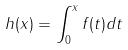Convert formula to latex. <formula><loc_0><loc_0><loc_500><loc_500>h ( x ) = \int _ { 0 } ^ { x } f ( t ) d t</formula> 